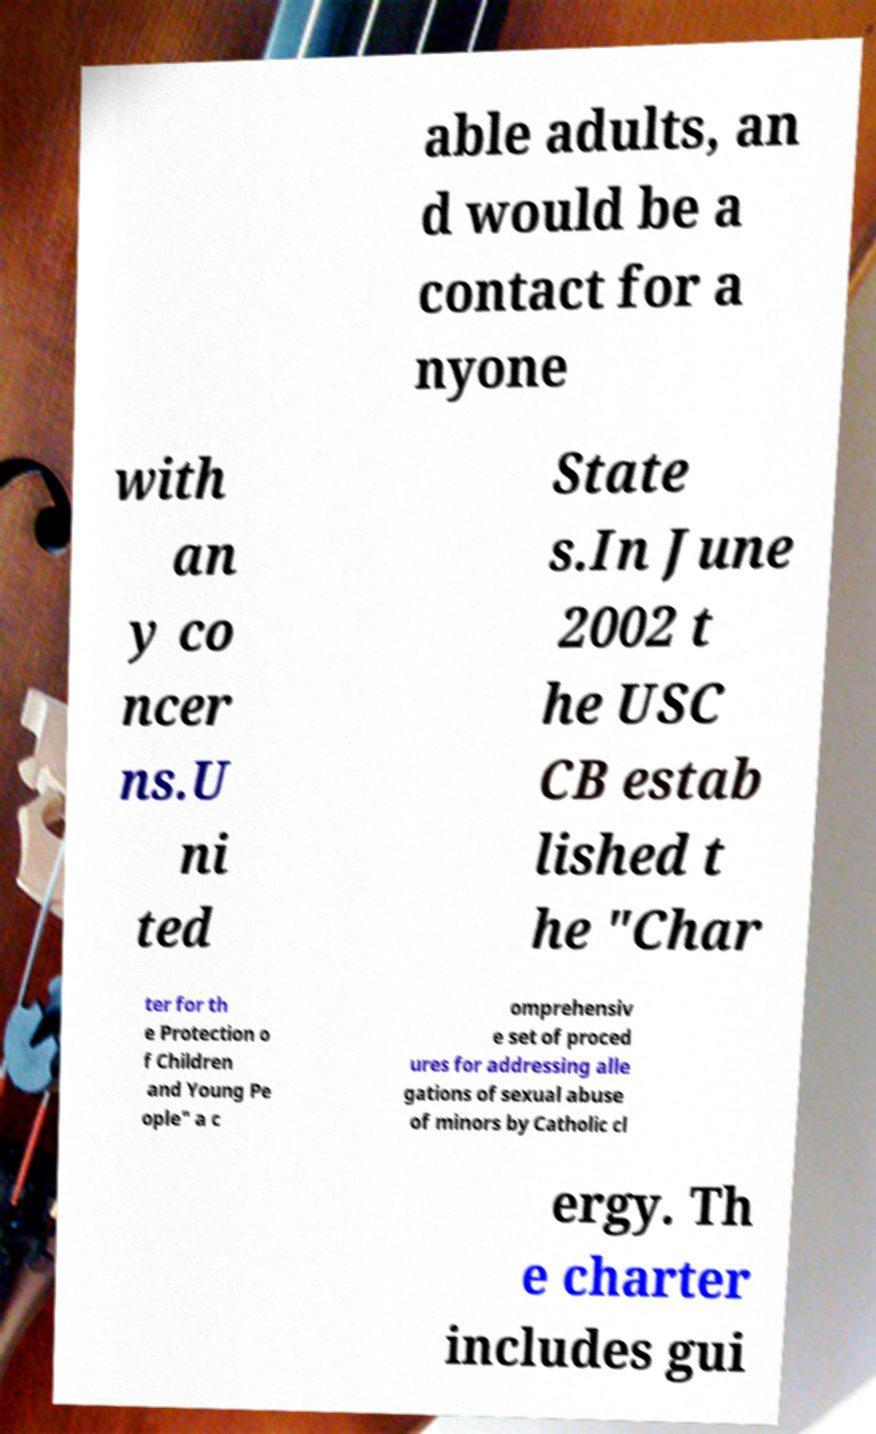Could you extract and type out the text from this image? able adults, an d would be a contact for a nyone with an y co ncer ns.U ni ted State s.In June 2002 t he USC CB estab lished t he "Char ter for th e Protection o f Children and Young Pe ople" a c omprehensiv e set of proced ures for addressing alle gations of sexual abuse of minors by Catholic cl ergy. Th e charter includes gui 